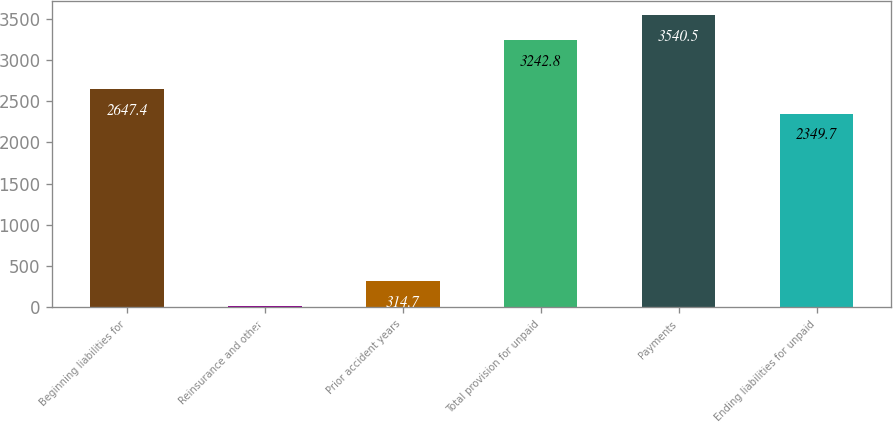<chart> <loc_0><loc_0><loc_500><loc_500><bar_chart><fcel>Beginning liabilities for<fcel>Reinsurance and other<fcel>Prior accident years<fcel>Total provision for unpaid<fcel>Payments<fcel>Ending liabilities for unpaid<nl><fcel>2647.4<fcel>17<fcel>314.7<fcel>3242.8<fcel>3540.5<fcel>2349.7<nl></chart> 